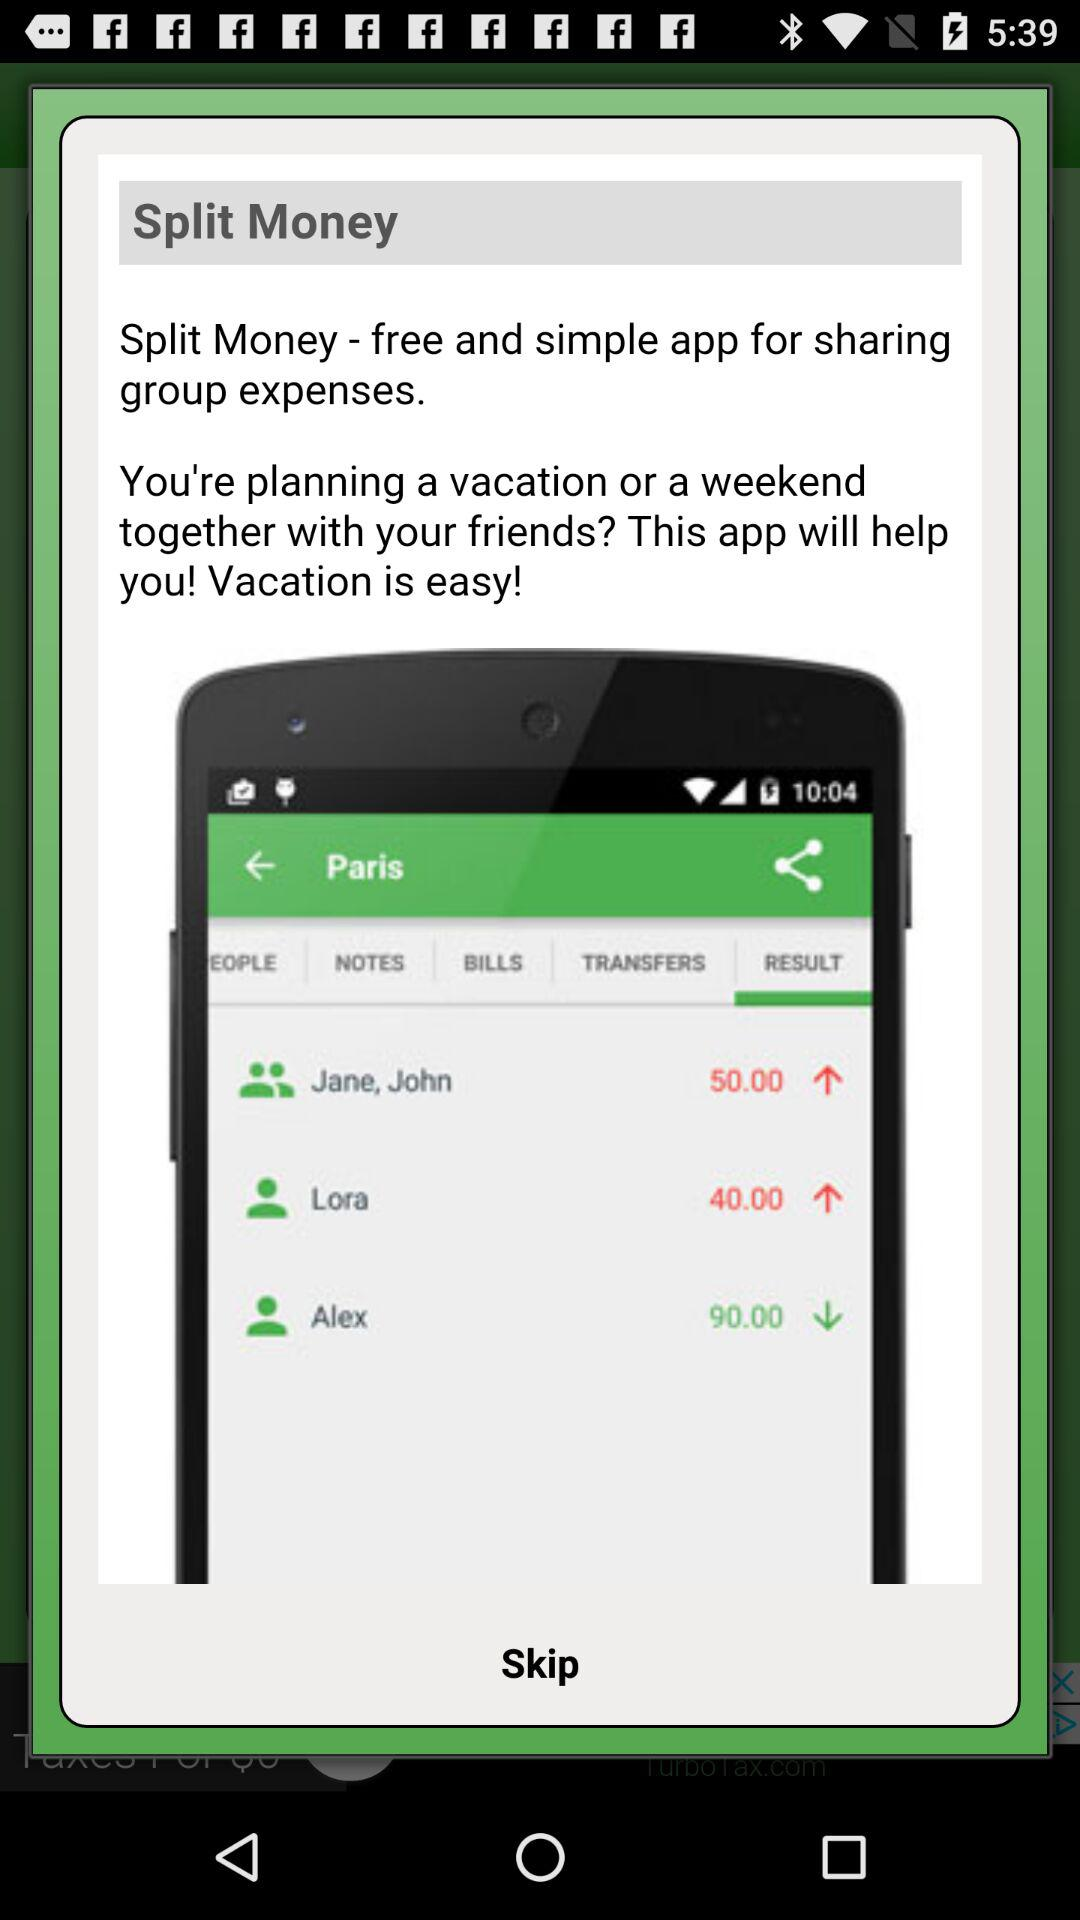What amount was paid to Lora for the traveling expenses to Paris? The amount that was paid to Lora for the traveling expenses to Paris is 40. 